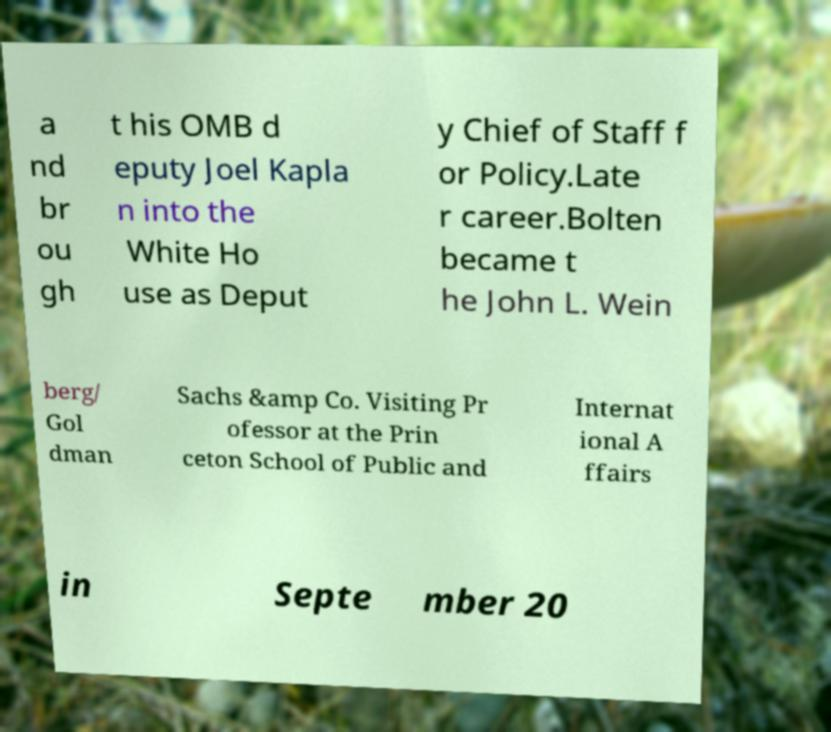Can you accurately transcribe the text from the provided image for me? a nd br ou gh t his OMB d eputy Joel Kapla n into the White Ho use as Deput y Chief of Staff f or Policy.Late r career.Bolten became t he John L. Wein berg/ Gol dman Sachs &amp Co. Visiting Pr ofessor at the Prin ceton School of Public and Internat ional A ffairs in Septe mber 20 